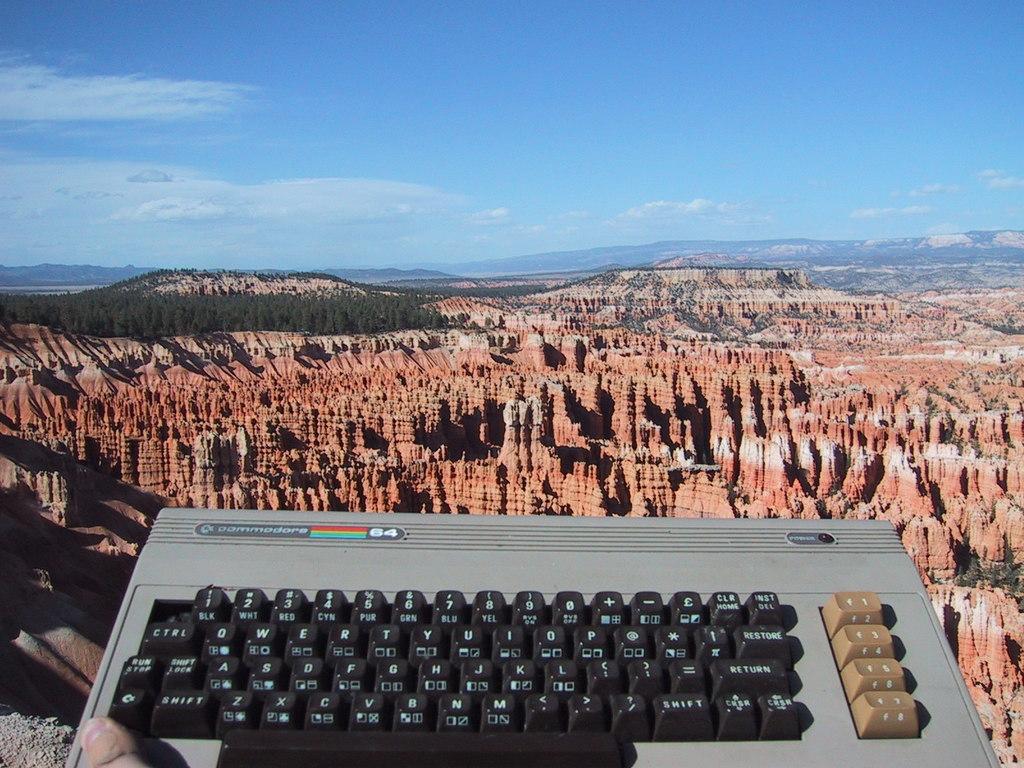What computer is this?
Keep it short and to the point. Unanswerable. What is the word on the upper left of this typewriter?
Offer a terse response. Commodore. 